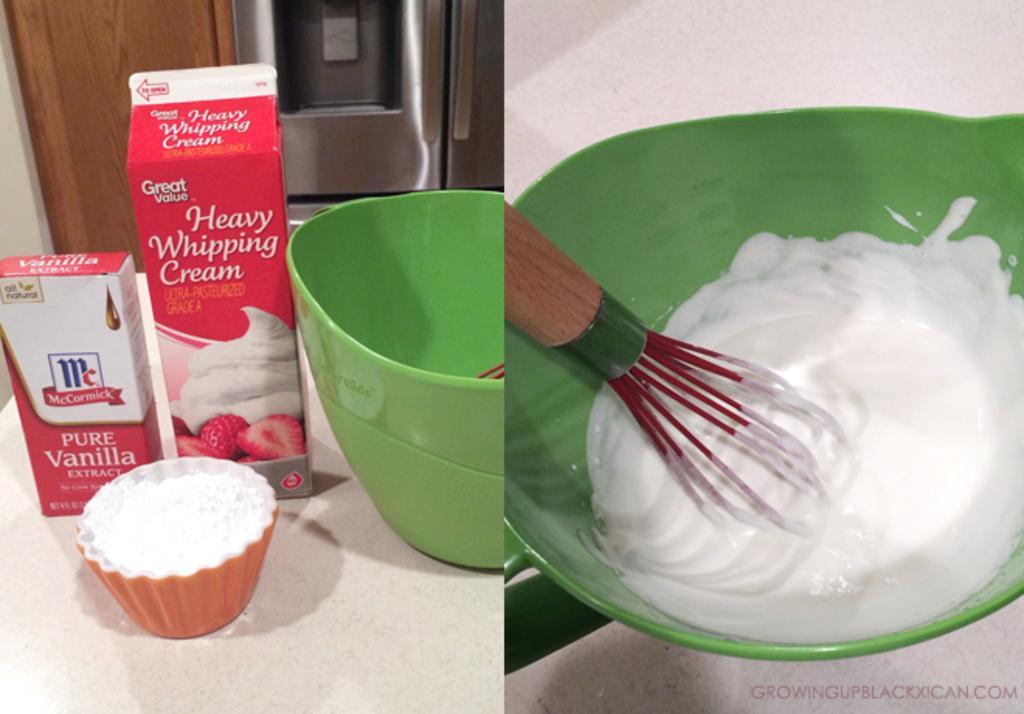Could you give a brief overview of what you see in this image? On the left side of the image there is a table with green bowl, two packets and one small bowl with flour in it. Behind them there is a refrigerator and also there is a wooden object. And on the right side of the image there is a green bowl with cream and a whisk in it. 